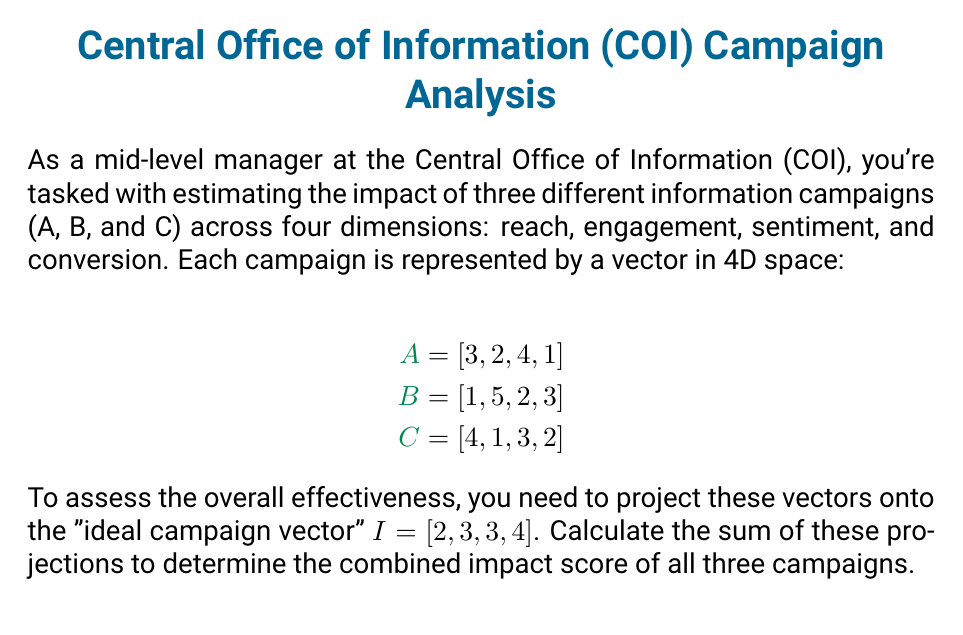Show me your answer to this math problem. Let's approach this step-by-step:

1) The projection of a vector $\mathbf{a}$ onto a vector $\mathbf{b}$ is given by:

   $$\text{proj}_\mathbf{b}\mathbf{a} = \frac{\mathbf{a} \cdot \mathbf{b}}{\|\mathbf{b}\|^2} \mathbf{b}$$

2) First, we need to calculate $\|\mathbf{I}\|^2$:
   
   $$\|\mathbf{I}\|^2 = 2^2 + 3^2 + 3^2 + 4^2 = 4 + 9 + 9 + 16 = 38$$

3) Now, let's calculate the dot products:

   $\mathbf{A} \cdot \mathbf{I} = 3(2) + 2(3) + 4(3) + 1(4) = 6 + 6 + 12 + 4 = 28$
   
   $\mathbf{B} \cdot \mathbf{I} = 1(2) + 5(3) + 2(3) + 3(4) = 2 + 15 + 6 + 12 = 35$
   
   $\mathbf{C} \cdot \mathbf{I} = 4(2) + 1(3) + 3(3) + 2(4) = 8 + 3 + 9 + 8 = 28$

4) Now we can calculate the scalar projections:

   $\text{proj}_\mathbf{I}\mathbf{A} = \frac{28}{38} = \frac{14}{19}$
   
   $\text{proj}_\mathbf{I}\mathbf{B} = \frac{35}{38}$
   
   $\text{proj}_\mathbf{I}\mathbf{C} = \frac{28}{38} = \frac{14}{19}$

5) The sum of these projections gives us the combined impact score:

   $$\text{Impact Score} = \frac{14}{19} + \frac{35}{38} + \frac{14}{19} = \frac{28}{19} + \frac{35}{38} = \frac{1064}{722} + \frac{665}{722} = \frac{1729}{722} \approx 2.394$$
Answer: $\frac{1729}{722}$ or approximately 2.394 